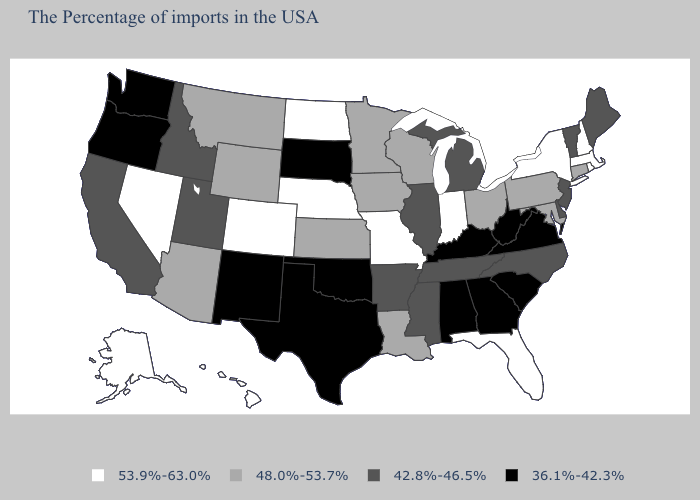Name the states that have a value in the range 53.9%-63.0%?
Keep it brief. Massachusetts, Rhode Island, New Hampshire, New York, Florida, Indiana, Missouri, Nebraska, North Dakota, Colorado, Nevada, Alaska, Hawaii. Among the states that border Indiana , which have the lowest value?
Concise answer only. Kentucky. What is the value of Idaho?
Be succinct. 42.8%-46.5%. What is the lowest value in the USA?
Answer briefly. 36.1%-42.3%. Does Oklahoma have the lowest value in the USA?
Concise answer only. Yes. Name the states that have a value in the range 48.0%-53.7%?
Write a very short answer. Connecticut, Maryland, Pennsylvania, Ohio, Wisconsin, Louisiana, Minnesota, Iowa, Kansas, Wyoming, Montana, Arizona. Does New Mexico have the lowest value in the West?
Concise answer only. Yes. What is the highest value in states that border Michigan?
Give a very brief answer. 53.9%-63.0%. What is the value of Florida?
Write a very short answer. 53.9%-63.0%. Which states hav the highest value in the Northeast?
Write a very short answer. Massachusetts, Rhode Island, New Hampshire, New York. What is the value of Tennessee?
Write a very short answer. 42.8%-46.5%. What is the highest value in the USA?
Answer briefly. 53.9%-63.0%. Which states have the lowest value in the West?
Answer briefly. New Mexico, Washington, Oregon. Does Oregon have the lowest value in the USA?
Give a very brief answer. Yes. What is the value of New Mexico?
Short answer required. 36.1%-42.3%. 